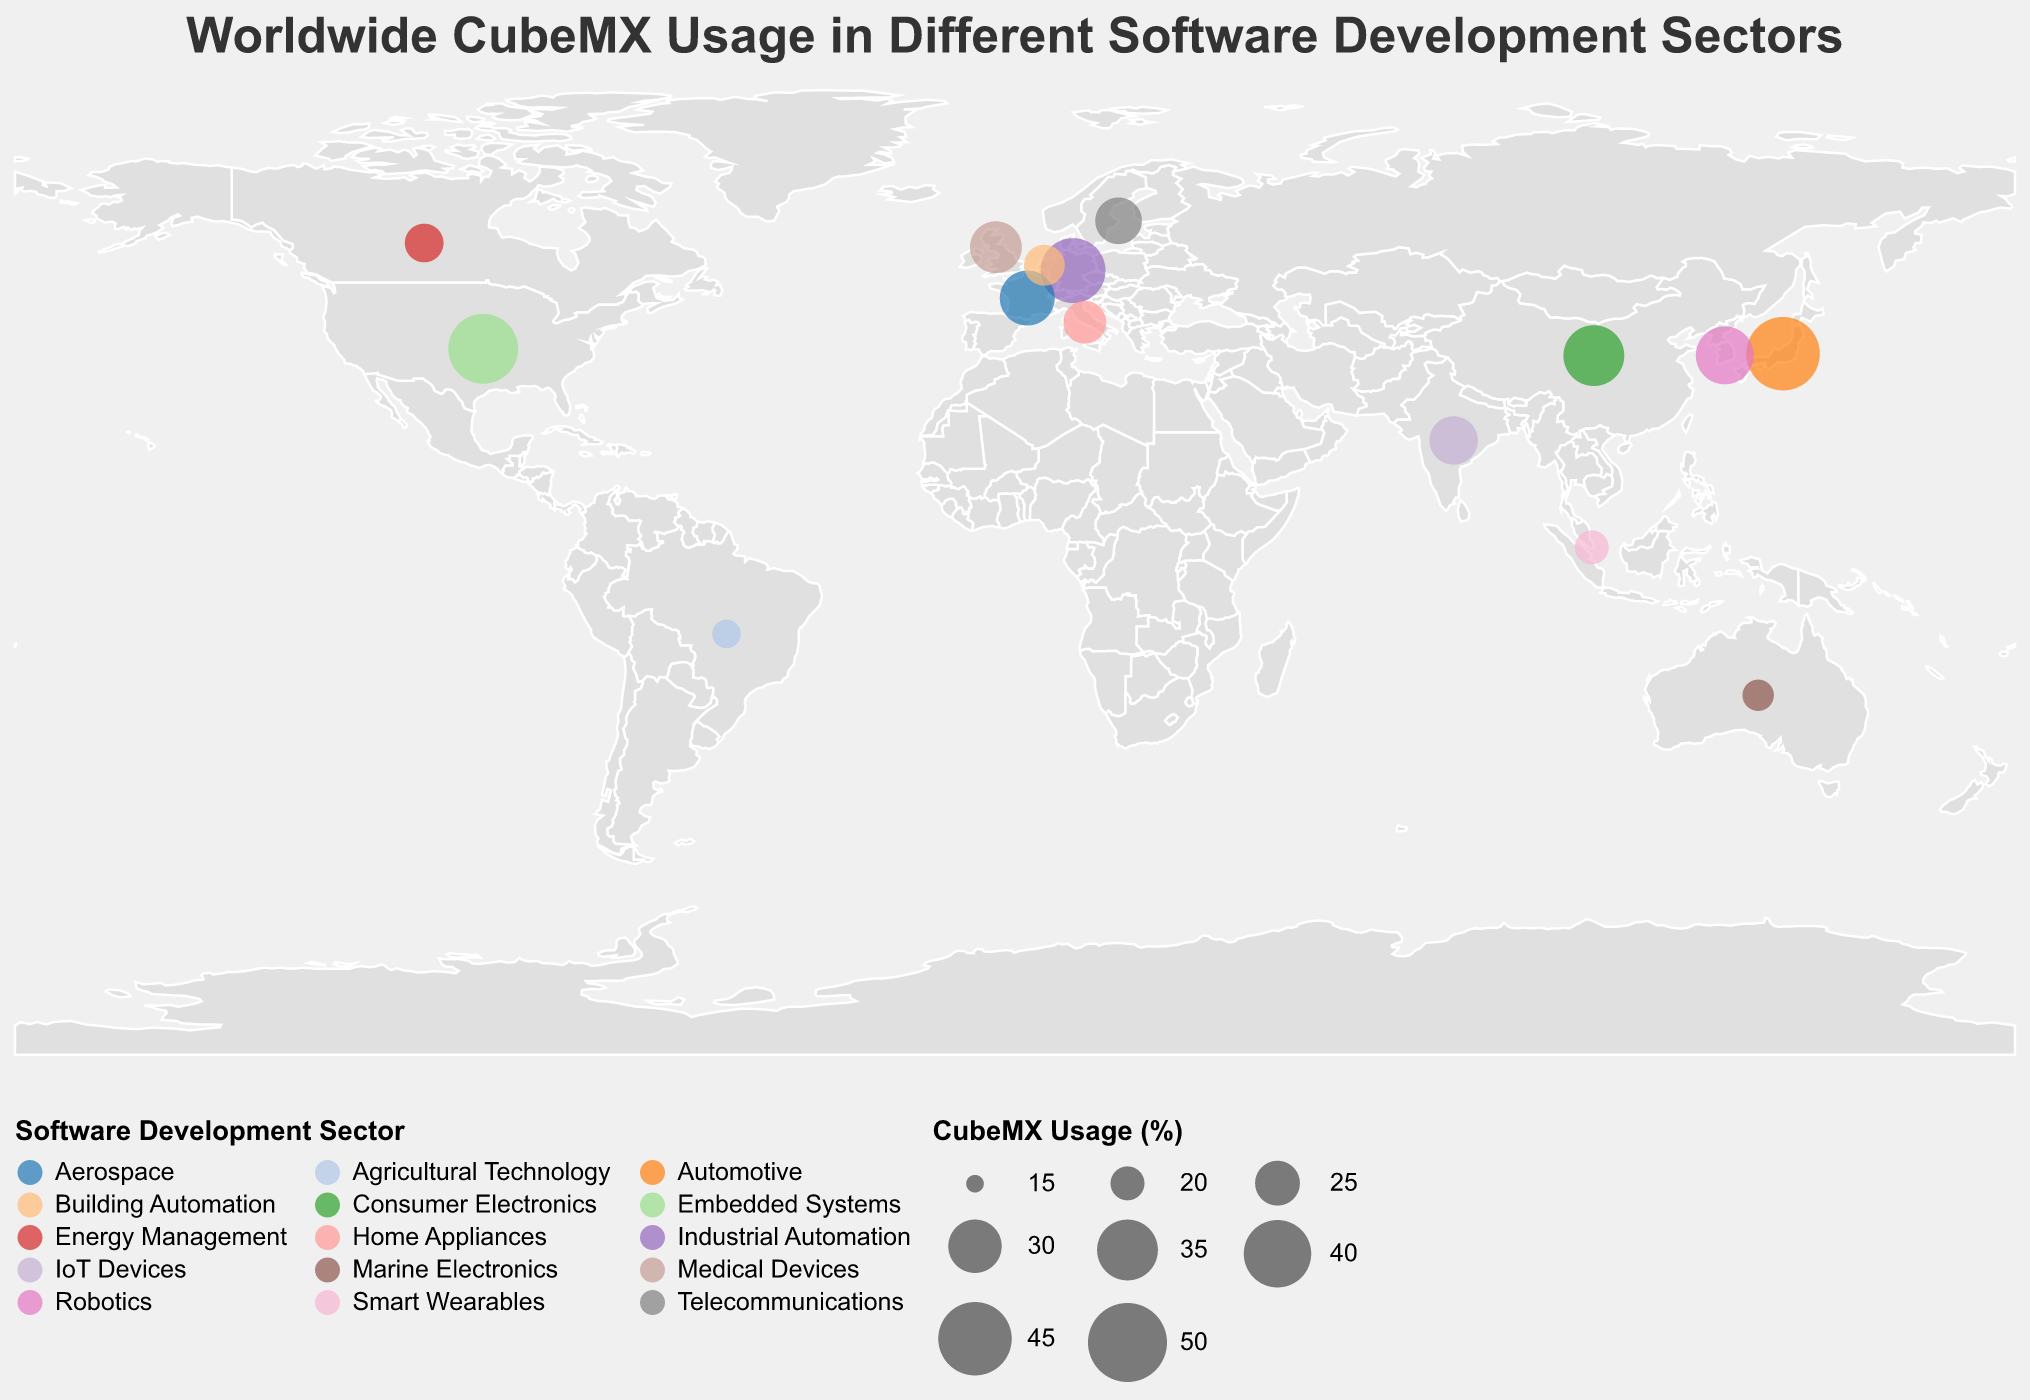What is the CubeMX usage percentage in Japan for the Automotive sector? The figure provides data points showing CubeMX usage percentages for different countries and sectors. Specifically, you can find that Japan has a usage percentage for the Automotive sector.
Answer: 45 Which country has the lowest CubeMX usage percentage? Referring to the plot, identify the data point with the smallest circle size or lowest CubeMX usage percentage value, which represents Brazil, listed with 18%.
Answer: Brazil Which countries have a CubeMX usage percentage of less than 30%? By scanning through the circles in the plot, locate those with usage percentages below 30%. This includes the United Kingdom, India, Italy, Canada, Sweden, Singapore, Brazil, Netherlands, and Australia.
Answer: United Kingdom, India, Italy, Canada, Sweden, Singapore, Brazil, Netherlands, Australia Compare the CubeMX usage percentages between the United States and France. Which one is higher and by how much? The CubeMX usage percentage for the United States is 42%, and for France, it is 31%. Thus, the United States has a higher usage percentage. Subtract the percentage for France from that of the United States to find the difference: 42 - 31 = 11%.
Answer: United States by 11% What is the total CubeMX usage percentage for all the European countries combined? Sum the CubeMX usage percentages for Germany (38%), France (31%), United Kingdom (29%), Italy (24%), Netherlands (23%), and Sweden (26%). The total is: 38 + 31 + 29 + 24 + 23 + 26 = 171%.
Answer: 171% Which sector within South Korea is represented in the plot? Locate South Korea on the plot and check the corresponding sector. The sector for South Korea is Robotics.
Answer: Robotics How does the CubeMX usage in the Medical Devices sector (United Kingdom) compare to the CubeMX usage in the Smart Wearables sector (Singapore)? The CubeMX usage percentage for the Medical Devices sector in the United Kingdom is 29%, and for the Smart Wearables sector in Singapore, it is 20%. Comparing these, the CubeMX usage is higher in the Medical Devices sector by 29 - 20 = 9%.
Answer: Medical Devices by 9% What is the mean CubeMX usage percentage for all countries combined? Sum all the CubeMX usage percentages and divide by the number of countries (15). The total sum is: 42 + 38 + 35 + 45 + 31 + 29 + 33 + 27 + 24 + 22 + 26 + 20 + 18 + 23 + 19 = 432%. The mean usage percentage is: 432 / 15 = 28.8%.
Answer: 28.8% Identify the country with the highest CubeMX usage percentage and explain how you found it. The plot shows different circle sizes corresponding to CubeMX usage percentages. Find the largest circle or highest value, which is Japan with a percentage of 45%.
Answer: Japan 